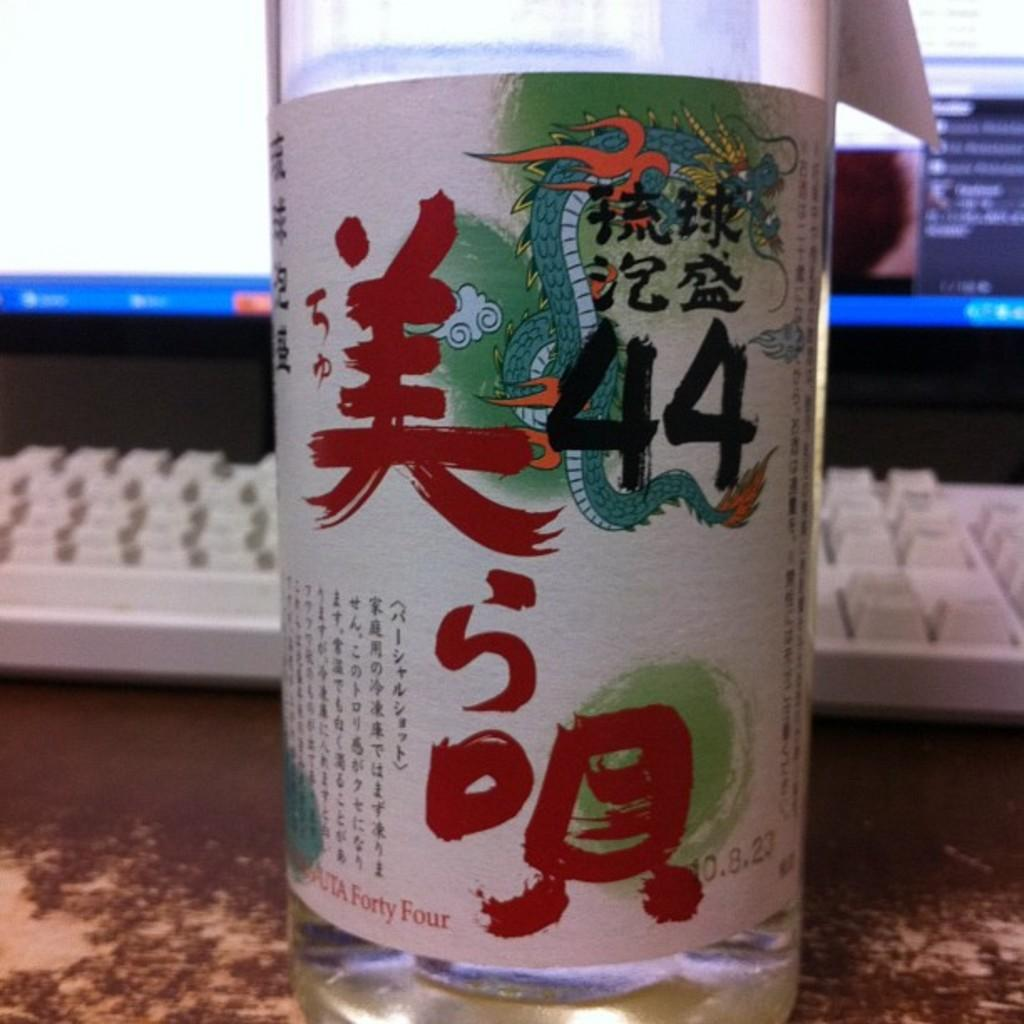<image>
Render a clear and concise summary of the photo. A bottle with the text 44 on the label is on a desk along with a keyboard and monitor. 